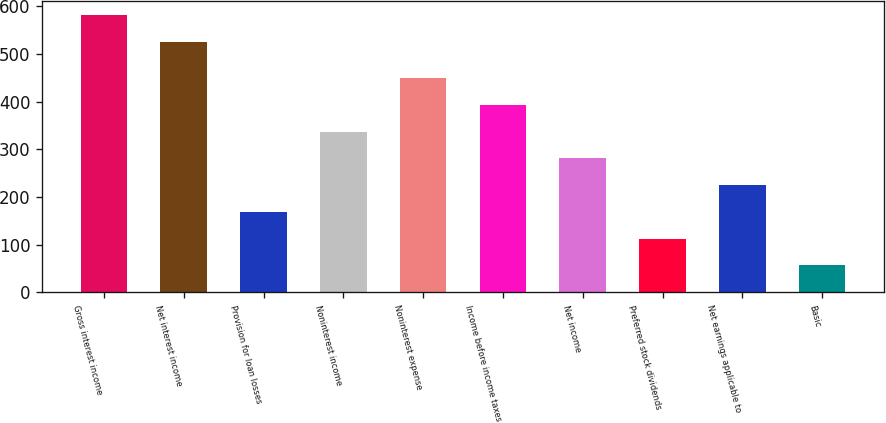<chart> <loc_0><loc_0><loc_500><loc_500><bar_chart><fcel>Gross interest income<fcel>Net interest income<fcel>Provision for loan losses<fcel>Noninterest income<fcel>Noninterest expense<fcel>Income before income taxes<fcel>Net income<fcel>Preferred stock dividends<fcel>Net earnings applicable to<fcel>Basic<nl><fcel>582.15<fcel>526<fcel>168.99<fcel>337.44<fcel>449.74<fcel>393.59<fcel>281.29<fcel>112.84<fcel>225.14<fcel>56.69<nl></chart> 